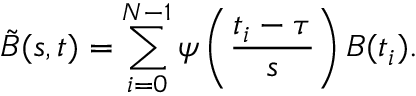<formula> <loc_0><loc_0><loc_500><loc_500>\tilde { B } ( s , t ) = \sum _ { i = 0 } ^ { N - 1 } \psi \left ( \frac { t _ { i } - \tau } { s } \right ) B ( t _ { i } ) .</formula> 